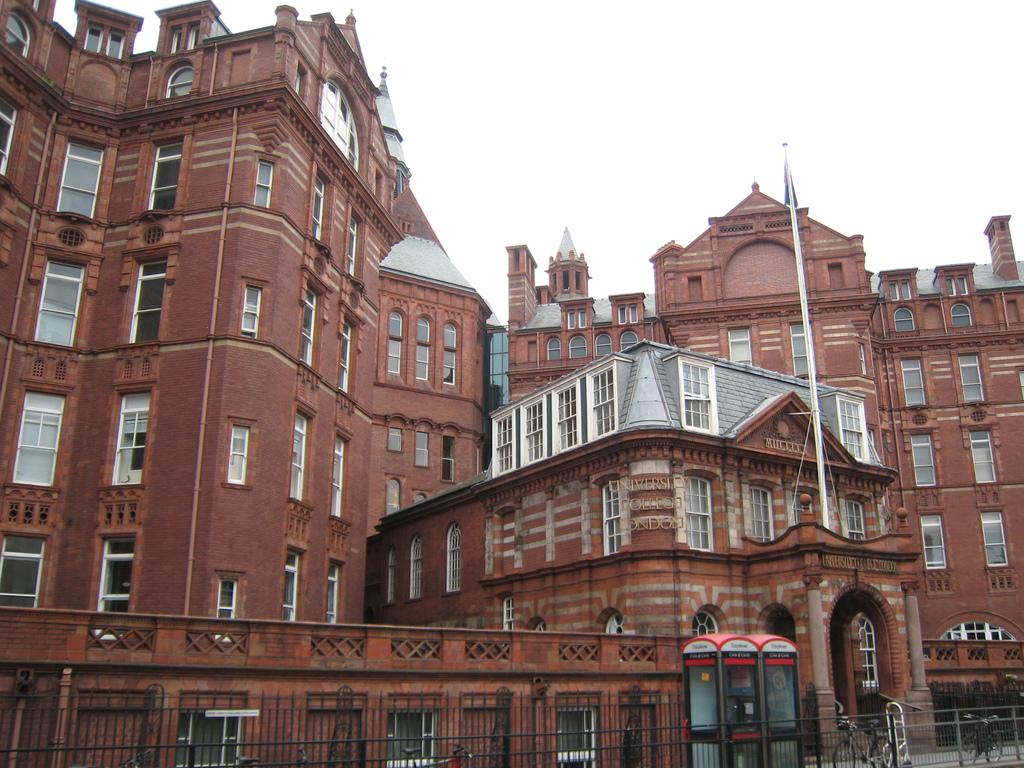What type of structures can be seen in the image? There are buildings in the image. What is the purpose of the fence in the image? The fence is present in the image, but its purpose is not explicitly stated. What is the booth in the image used for? The purpose of the booth in the image is not specified. What mode of transportation can be seen on the path? Bicycles are present on the path in the image. What is attached to the flag in the image? A flag with a pole is present in the image. What part of the natural environment is visible in the image? The sky is visible in the image. What type of shoes can be seen on the flag in the image? There are no shoes present on the flag in the image; it is a flag with a pole. What news is being reported by the clouds in the image? There are no clouds or news being reported in the image; it features a flag with a pole, buildings, a fence, a booth, bicycles, and the sky. 